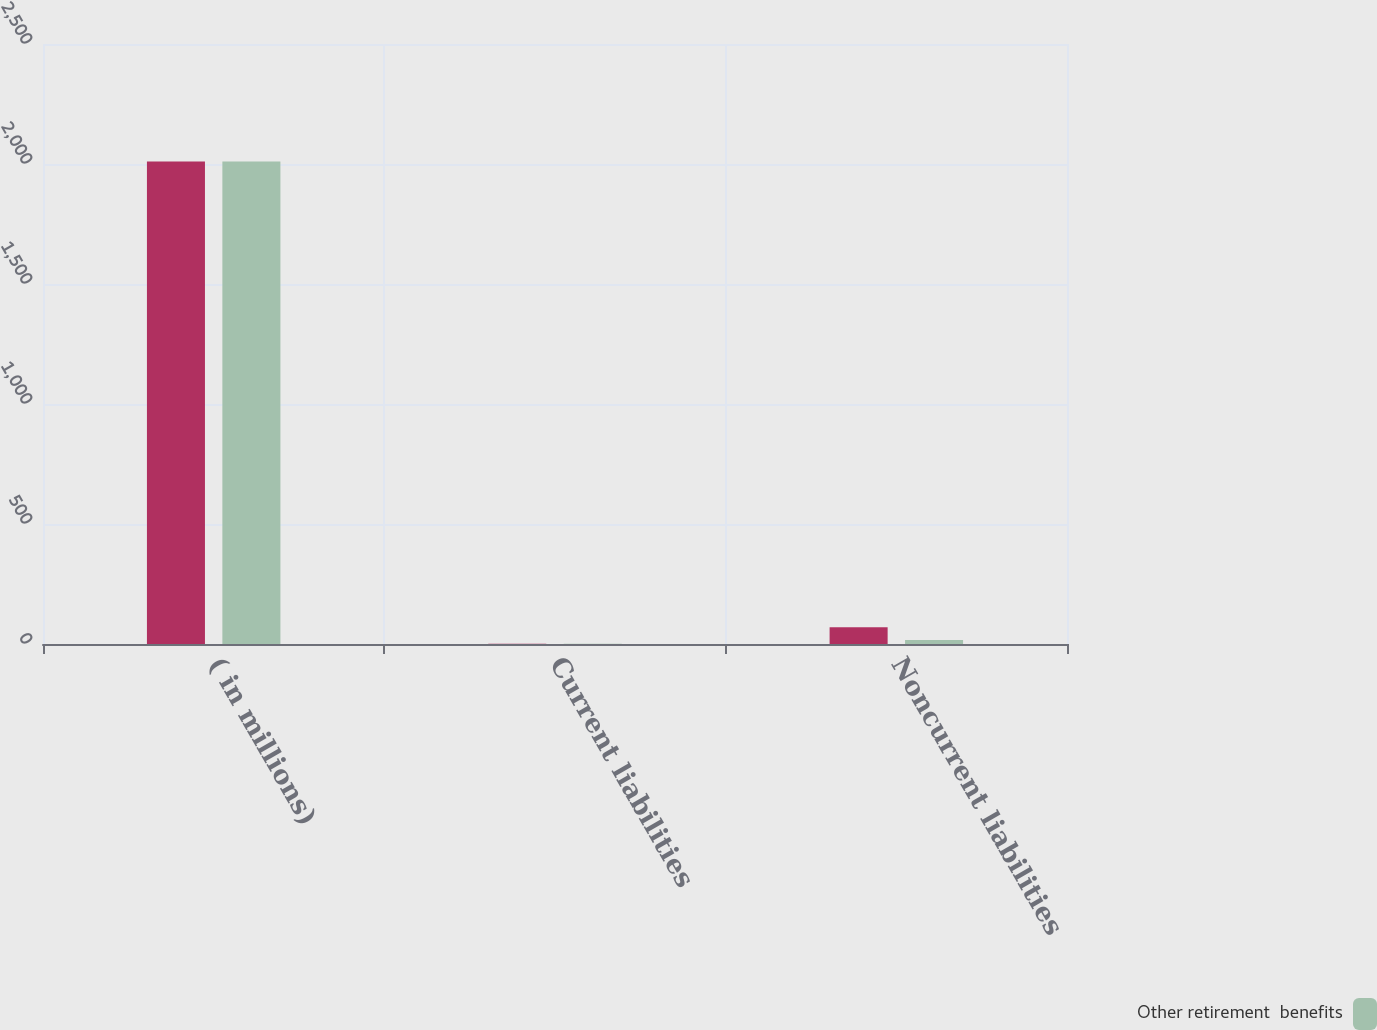Convert chart. <chart><loc_0><loc_0><loc_500><loc_500><stacked_bar_chart><ecel><fcel>( in millions)<fcel>Current liabilities<fcel>Noncurrent liabilities<nl><fcel>nan<fcel>2010<fcel>1.1<fcel>70.1<nl><fcel>Other retirement  benefits<fcel>2010<fcel>1<fcel>17.1<nl></chart> 